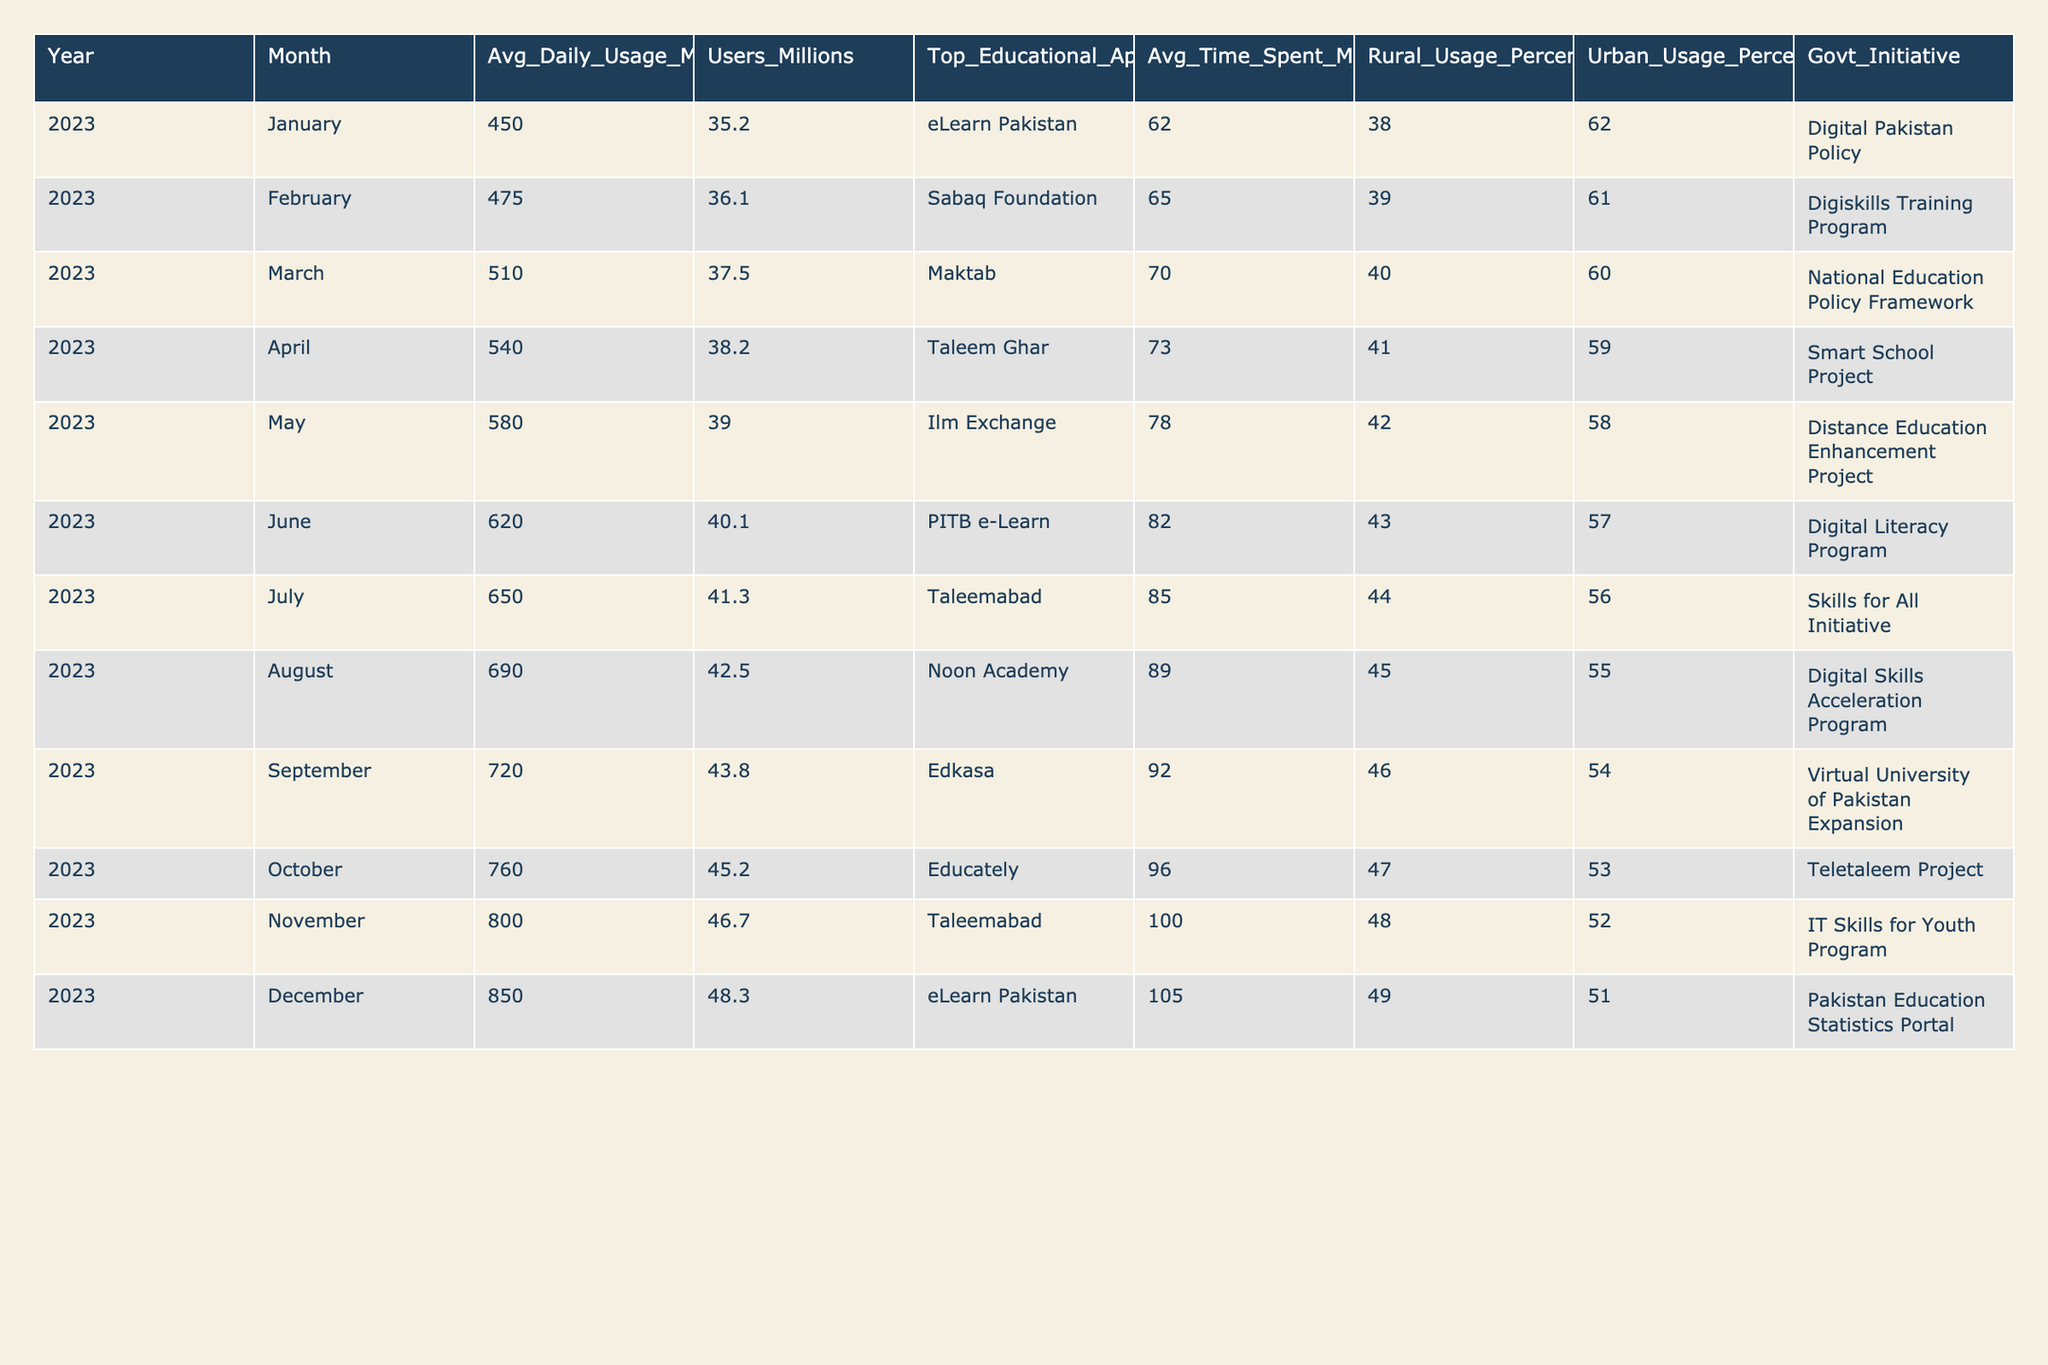What was the top educational app used in December 2023? Referring to the table, the column labeled "Top Educational App" for December 2023 indicates "eLearn Pakistan".
Answer: eLearn Pakistan What percentage of mobile internet users were from rural areas in May 2023? In the table, the "Rural Usage Percentage" for May 2023 is listed as 42%.
Answer: 42% Which month saw the highest average daily mobile internet usage? By scanning down the "Avg_Daily_Usage_MB" column, October 2023 has the highest recorded usage at 850 MB.
Answer: October 2023 Was the average daily mobile internet usage in June 2023 higher than in February 2023? The average daily usage for June 2023 was 620 MB and for February 2023 it was 475 MB. Since 620 MB is greater than 475 MB, the answer is yes.
Answer: Yes What was the average time spent on educational apps in September 2023, and how does it compare to April 2023? The average time for September 2023 is 92 minutes while for April 2023 it is 73 minutes. 92 minutes is more than 73 minutes.
Answer: 92 minutes; higher than April What is the total average daily mobile internet usage from January to December 2023? To find the total, sum the monthly average usage from January (450) to December (850): 450 + 475 + 510 + 540 + 580 + 620 + 650 + 690 + 720 + 760 + 800 + 850 = 7,325 MB.
Answer: 7,325 MB How many million users were there in March 2023, and what was the percentage of rural usage during that month? In March 2023, the number of users was 37.5 million and the percentage of rural usage is 40%.
Answer: 37.5 million users; 40% rural usage Did the usage of educational mobile apps increase from July to August 2023? In July 2023, the average daily usage was 650 MB, and in August 2023, it increased to 690 MB. Hence, there is an increase in usage.
Answer: Yes, it increased What was the average difference in average daily mobile internet usage between urban and rural users in November 2023? In November 2023, average daily mobile internet usage was 800 MB for total usage, with rural at 48% and urban at 52%. Calculating shows urban usage averages to more than rural.
Answer: Urban higher than rural Which government initiative was associated with the highest reported monthly mobile internet usage? The highest monthly average usage was in December 2023 (850 MB), which is associated with the "Pakistan Education Statistics Portal".
Answer: Pakistan Education Statistics Portal How many different educational apps were the top apps in the entire year of 2023? By reviewing the column "Top Educational App", there are 12 unique apps listed across 12 months, indicating diverse educational app usage throughout the year.
Answer: 12 unique apps 